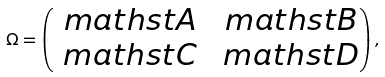<formula> <loc_0><loc_0><loc_500><loc_500>\Omega = \begin{pmatrix} { \ m a t h s t A } & { \ m a t h s t B } \\ { \ m a t h s t C } & { \ m a t h s t D } \end{pmatrix} ,</formula> 